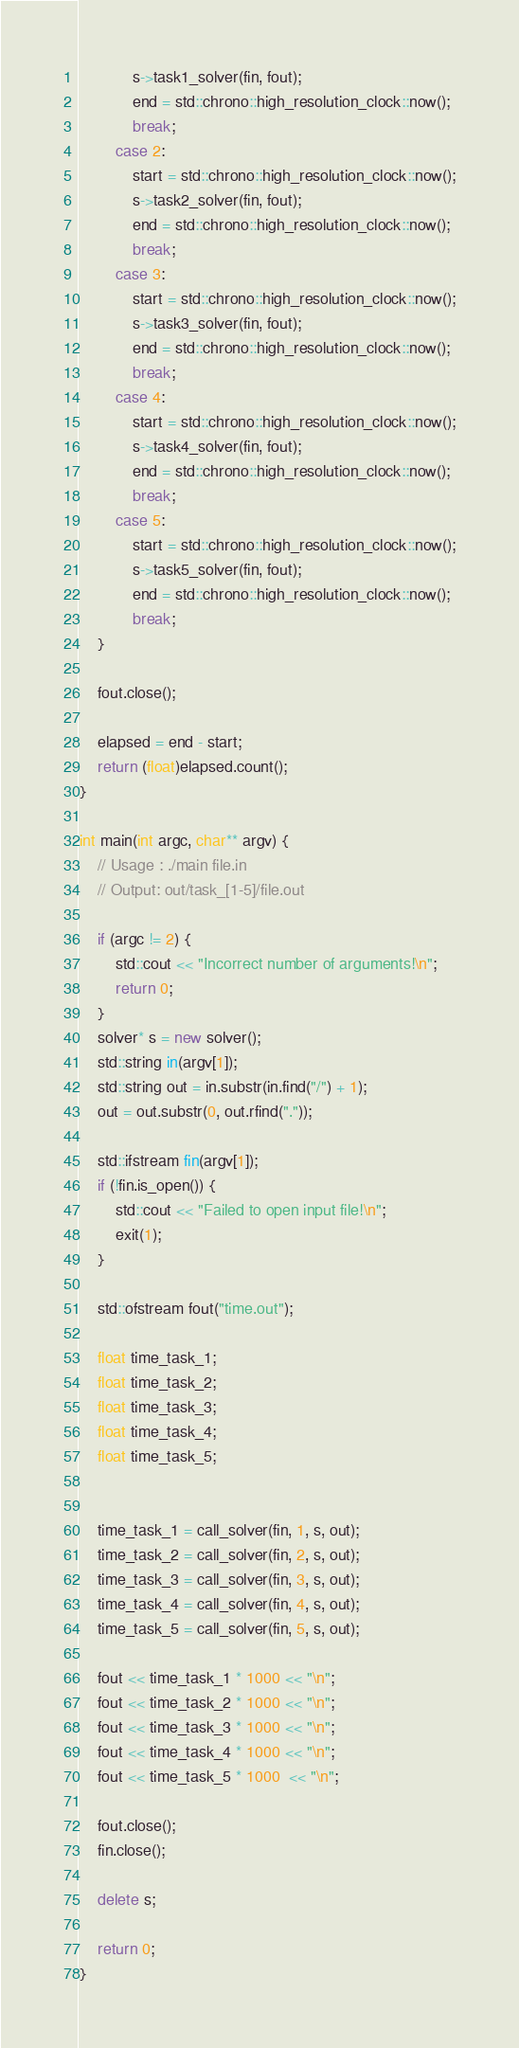Convert code to text. <code><loc_0><loc_0><loc_500><loc_500><_C++_>			s->task1_solver(fin, fout);
			end = std::chrono::high_resolution_clock::now();
			break;
		case 2:
			start = std::chrono::high_resolution_clock::now();
			s->task2_solver(fin, fout);
			end = std::chrono::high_resolution_clock::now();
			break;
		case 3:
			start = std::chrono::high_resolution_clock::now();
			s->task3_solver(fin, fout);
			end = std::chrono::high_resolution_clock::now();
			break;
		case 4:
			start = std::chrono::high_resolution_clock::now();
			s->task4_solver(fin, fout);
			end = std::chrono::high_resolution_clock::now();
			break;
		case 5:
			start = std::chrono::high_resolution_clock::now();
			s->task5_solver(fin, fout);
			end = std::chrono::high_resolution_clock::now();
			break;
	}

	fout.close();

	elapsed = end - start;
	return (float)elapsed.count();
}

int main(int argc, char** argv) {
    // Usage : ./main file.in
    // Output: out/task_[1-5]/file.out

    if (argc != 2) {
        std::cout << "Incorrect number of arguments!\n";
        return 0;
    }
	solver* s = new solver();
    std::string in(argv[1]);
    std::string out = in.substr(in.find("/") + 1);
    out = out.substr(0, out.rfind("."));

	std::ifstream fin(argv[1]);
	if (!fin.is_open()) {
        std::cout << "Failed to open input file!\n";
        exit(1);
    }

    std::ofstream fout("time.out");

	float time_task_1;
	float time_task_2;
	float time_task_3;
	float time_task_4;
	float time_task_5;


	time_task_1 = call_solver(fin, 1, s, out);
	time_task_2 = call_solver(fin, 2, s, out);
	time_task_3 = call_solver(fin, 3, s, out);
	time_task_4 = call_solver(fin, 4, s, out);
	time_task_5 = call_solver(fin, 5, s, out);

	fout << time_task_1 * 1000 << "\n";
	fout << time_task_2 * 1000 << "\n";
	fout << time_task_3 * 1000 << "\n";
	fout << time_task_4 * 1000 << "\n";
	fout << time_task_5 * 1000  << "\n";

	fout.close();
	fin.close();

	delete s;

	return 0;
}
</code> 